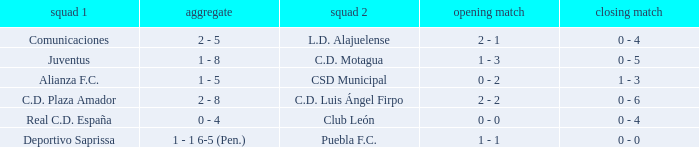What is the 2nd leg of the Comunicaciones team? 0 - 4. 